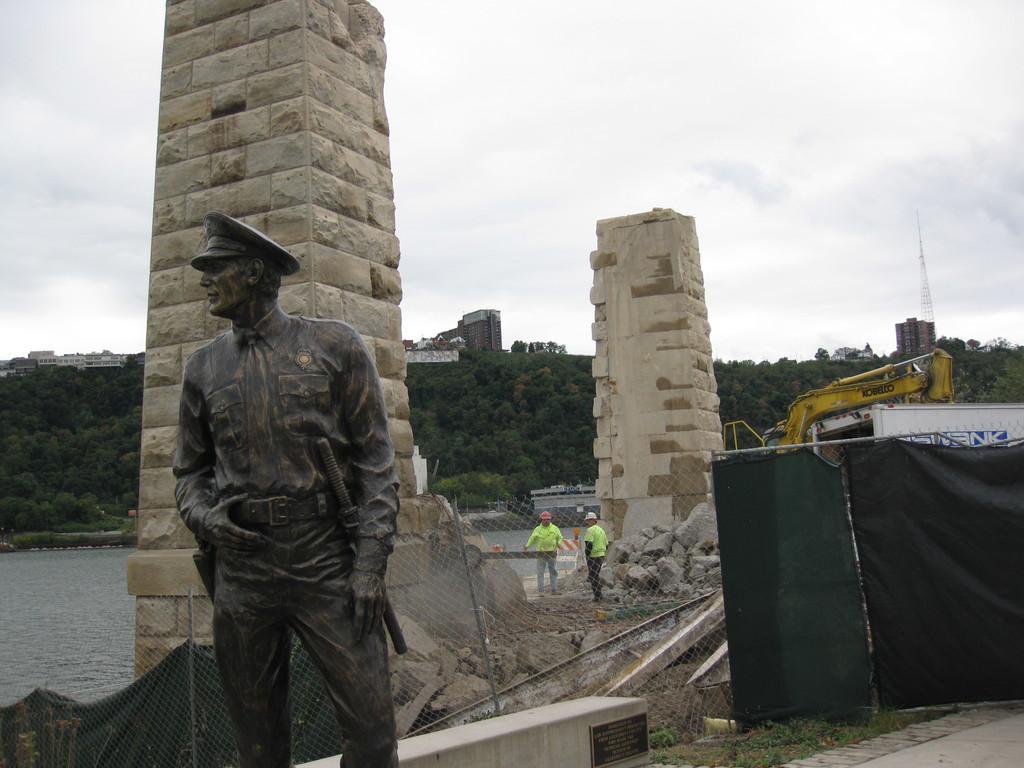In one or two sentences, can you explain what this image depicts? In this image I see a statue of a person over here and I see the fencing, black and green color cloth and in the background I see 2 persons over here and I see a vehicle over here and I see the water. I can also see number of trees and few buildings and I see the sky. 